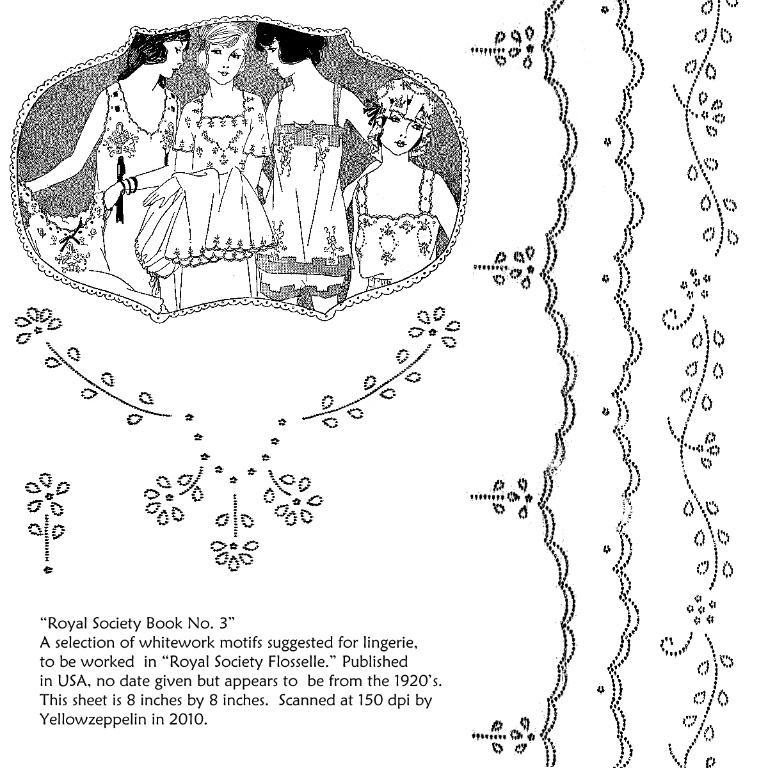What is the main object in the image? There is a drawing poster in the image. What can be found on the drawing poster? There is a quote written on the poster. What type of fuel is being used by the airplane in the image? There is no airplane present in the image, so it is not possible to determine what type of fuel is being used. 